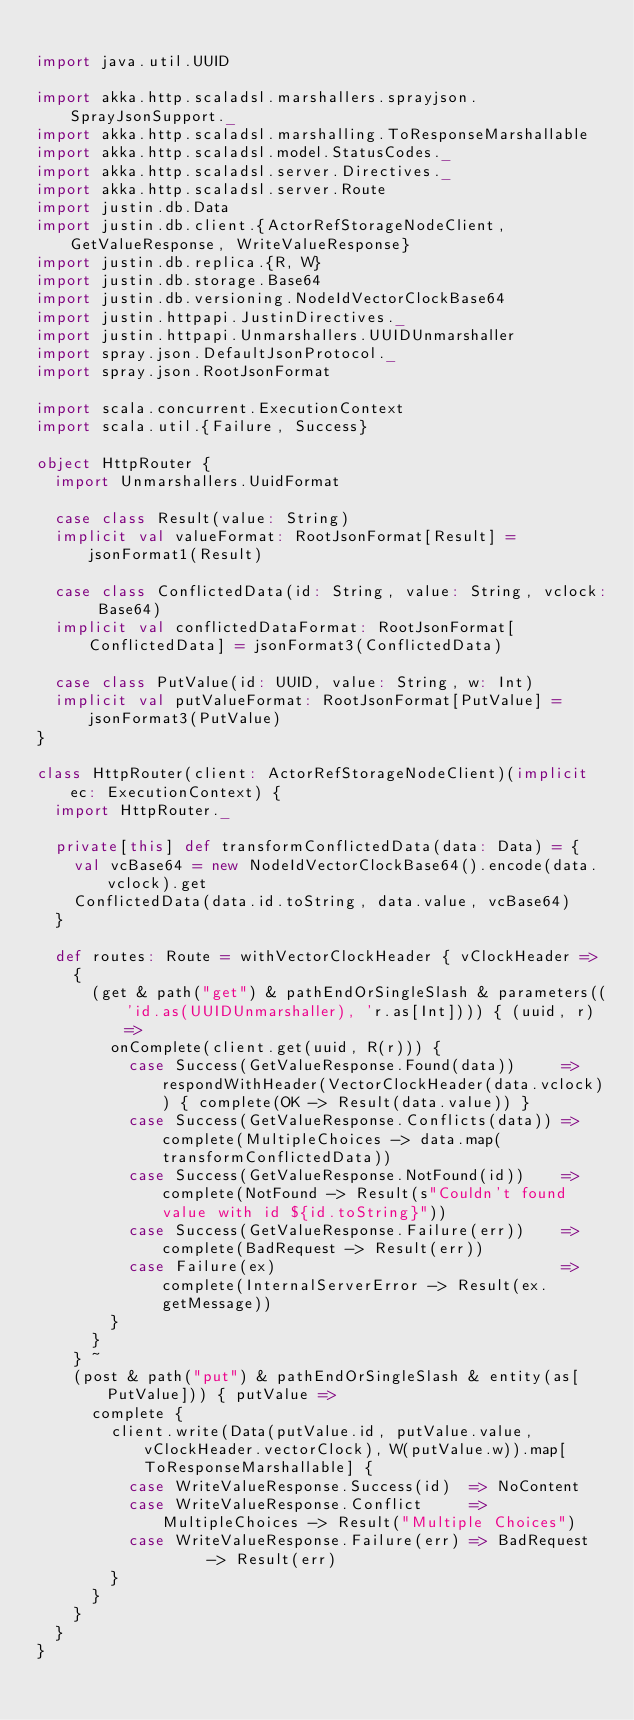<code> <loc_0><loc_0><loc_500><loc_500><_Scala_>
import java.util.UUID

import akka.http.scaladsl.marshallers.sprayjson.SprayJsonSupport._
import akka.http.scaladsl.marshalling.ToResponseMarshallable
import akka.http.scaladsl.model.StatusCodes._
import akka.http.scaladsl.server.Directives._
import akka.http.scaladsl.server.Route
import justin.db.Data
import justin.db.client.{ActorRefStorageNodeClient, GetValueResponse, WriteValueResponse}
import justin.db.replica.{R, W}
import justin.db.storage.Base64
import justin.db.versioning.NodeIdVectorClockBase64
import justin.httpapi.JustinDirectives._
import justin.httpapi.Unmarshallers.UUIDUnmarshaller
import spray.json.DefaultJsonProtocol._
import spray.json.RootJsonFormat

import scala.concurrent.ExecutionContext
import scala.util.{Failure, Success}

object HttpRouter {
  import Unmarshallers.UuidFormat

  case class Result(value: String)
  implicit val valueFormat: RootJsonFormat[Result] = jsonFormat1(Result)

  case class ConflictedData(id: String, value: String, vclock: Base64)
  implicit val conflictedDataFormat: RootJsonFormat[ConflictedData] = jsonFormat3(ConflictedData)

  case class PutValue(id: UUID, value: String, w: Int)
  implicit val putValueFormat: RootJsonFormat[PutValue] = jsonFormat3(PutValue)
}

class HttpRouter(client: ActorRefStorageNodeClient)(implicit ec: ExecutionContext) {
  import HttpRouter._

  private[this] def transformConflictedData(data: Data) = {
    val vcBase64 = new NodeIdVectorClockBase64().encode(data.vclock).get
    ConflictedData(data.id.toString, data.value, vcBase64)
  }

  def routes: Route = withVectorClockHeader { vClockHeader =>
    {
      (get & path("get") & pathEndOrSingleSlash & parameters(('id.as(UUIDUnmarshaller), 'r.as[Int]))) { (uuid, r) =>
        onComplete(client.get(uuid, R(r))) {
          case Success(GetValueResponse.Found(data))     => respondWithHeader(VectorClockHeader(data.vclock)) { complete(OK -> Result(data.value)) }
          case Success(GetValueResponse.Conflicts(data)) => complete(MultipleChoices -> data.map(transformConflictedData))
          case Success(GetValueResponse.NotFound(id))    => complete(NotFound -> Result(s"Couldn't found value with id ${id.toString}"))
          case Success(GetValueResponse.Failure(err))    => complete(BadRequest -> Result(err))
          case Failure(ex)                               => complete(InternalServerError -> Result(ex.getMessage))
        }
      }
    } ~
    (post & path("put") & pathEndOrSingleSlash & entity(as[PutValue])) { putValue =>
      complete {
        client.write(Data(putValue.id, putValue.value, vClockHeader.vectorClock), W(putValue.w)).map[ToResponseMarshallable] {
          case WriteValueResponse.Success(id)  => NoContent
          case WriteValueResponse.Conflict     => MultipleChoices -> Result("Multiple Choices")
          case WriteValueResponse.Failure(err) => BadRequest      -> Result(err)
        }
      }
    }
  }
}
</code> 